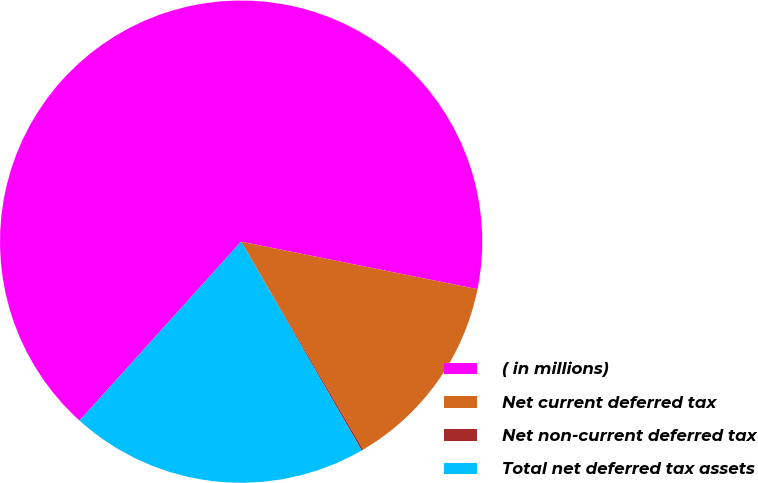Convert chart. <chart><loc_0><loc_0><loc_500><loc_500><pie_chart><fcel>( in millions)<fcel>Net current deferred tax<fcel>Net non-current deferred tax<fcel>Total net deferred tax assets<nl><fcel>66.47%<fcel>13.39%<fcel>0.12%<fcel>20.02%<nl></chart> 